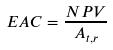<formula> <loc_0><loc_0><loc_500><loc_500>E A C = \frac { N P V } { A _ { t , r } }</formula> 